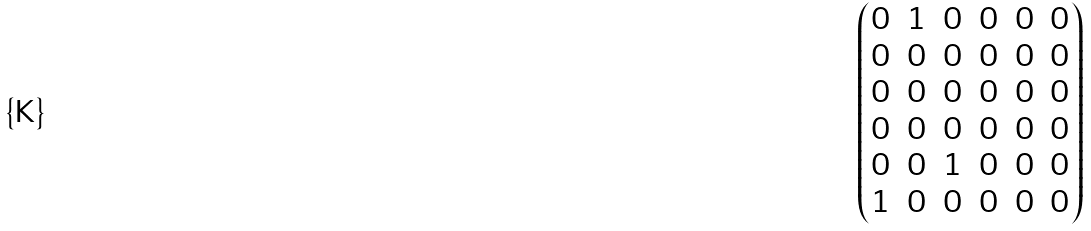<formula> <loc_0><loc_0><loc_500><loc_500>\begin{pmatrix} 0 & 1 & 0 & 0 & 0 & 0 \\ 0 & 0 & 0 & 0 & 0 & 0 \\ 0 & 0 & 0 & 0 & 0 & 0 \\ 0 & 0 & 0 & 0 & 0 & 0 \\ 0 & 0 & 1 & 0 & 0 & 0 \\ 1 & 0 & 0 & 0 & 0 & 0 \end{pmatrix}</formula> 